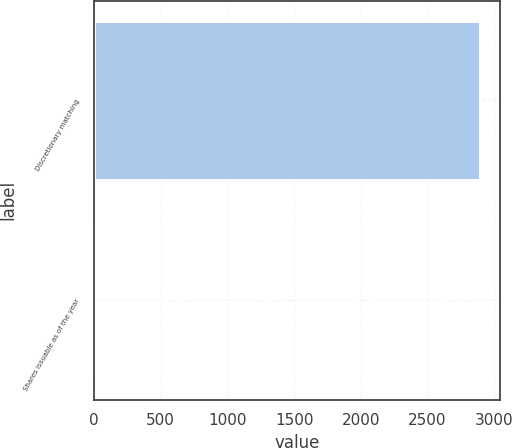Convert chart to OTSL. <chart><loc_0><loc_0><loc_500><loc_500><bar_chart><fcel>Discretionary matching<fcel>Shares issuable as of the year<nl><fcel>2894<fcel>19<nl></chart> 